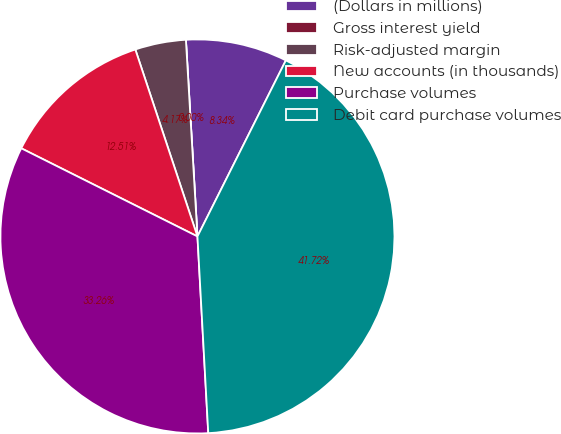Convert chart to OTSL. <chart><loc_0><loc_0><loc_500><loc_500><pie_chart><fcel>(Dollars in millions)<fcel>Gross interest yield<fcel>Risk-adjusted margin<fcel>New accounts (in thousands)<fcel>Purchase volumes<fcel>Debit card purchase volumes<nl><fcel>8.34%<fcel>0.0%<fcel>4.17%<fcel>12.51%<fcel>33.25%<fcel>41.71%<nl></chart> 